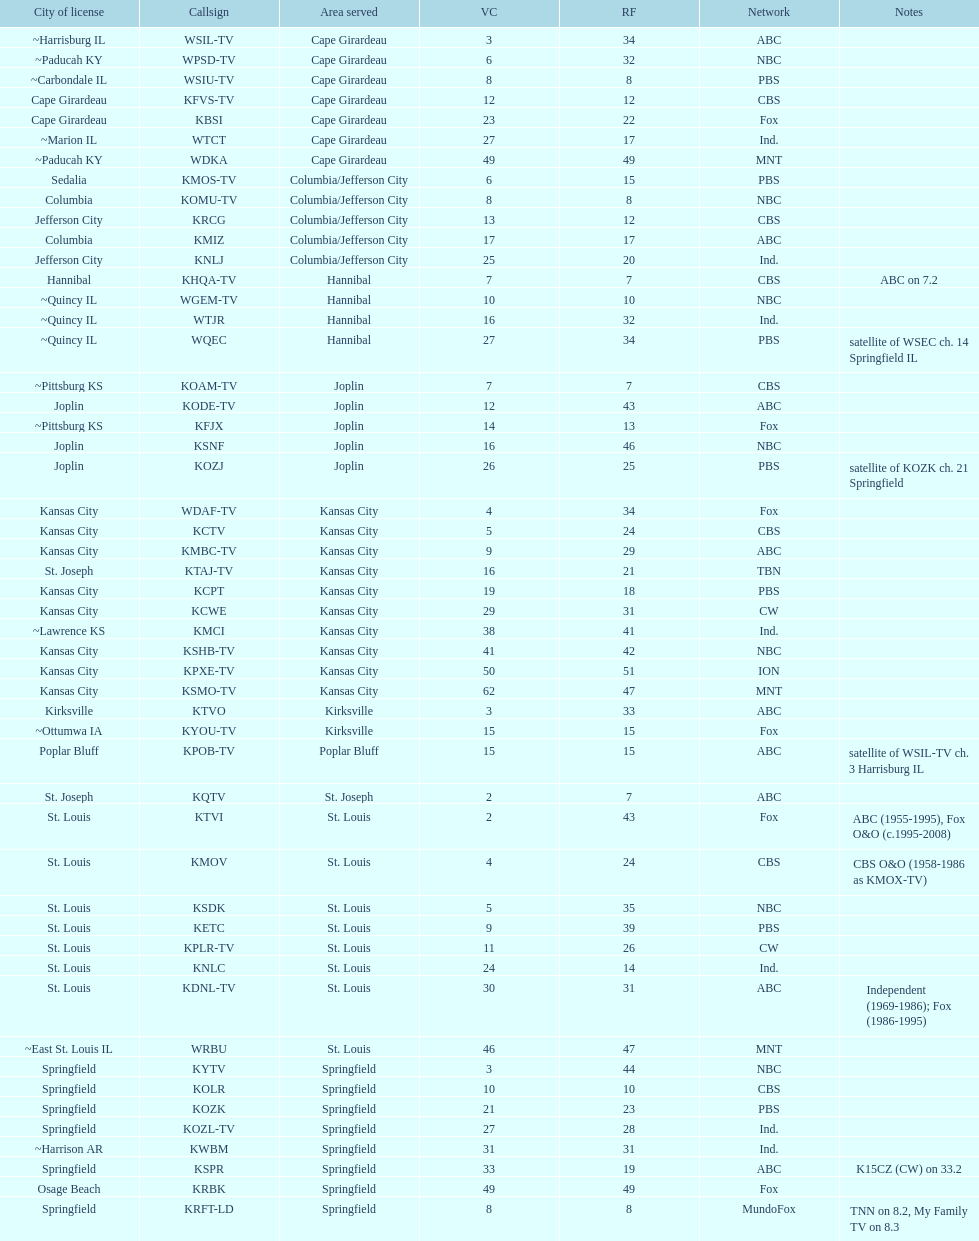How many areas have at least 5 stations? 6. 